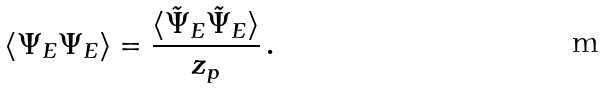<formula> <loc_0><loc_0><loc_500><loc_500>\langle \Psi _ { E } \Psi _ { E } \rangle = \frac { \langle \tilde { \Psi } _ { E } \tilde { \Psi } _ { E } \rangle } { z _ { p } } \, .</formula> 